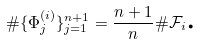<formula> <loc_0><loc_0><loc_500><loc_500>\# \{ \Phi _ { j } ^ { ( i ) } \} _ { j = 1 } ^ { n + 1 } = \frac { n + 1 } { n } \# \mathcal { F } _ { i } \text {.}</formula> 